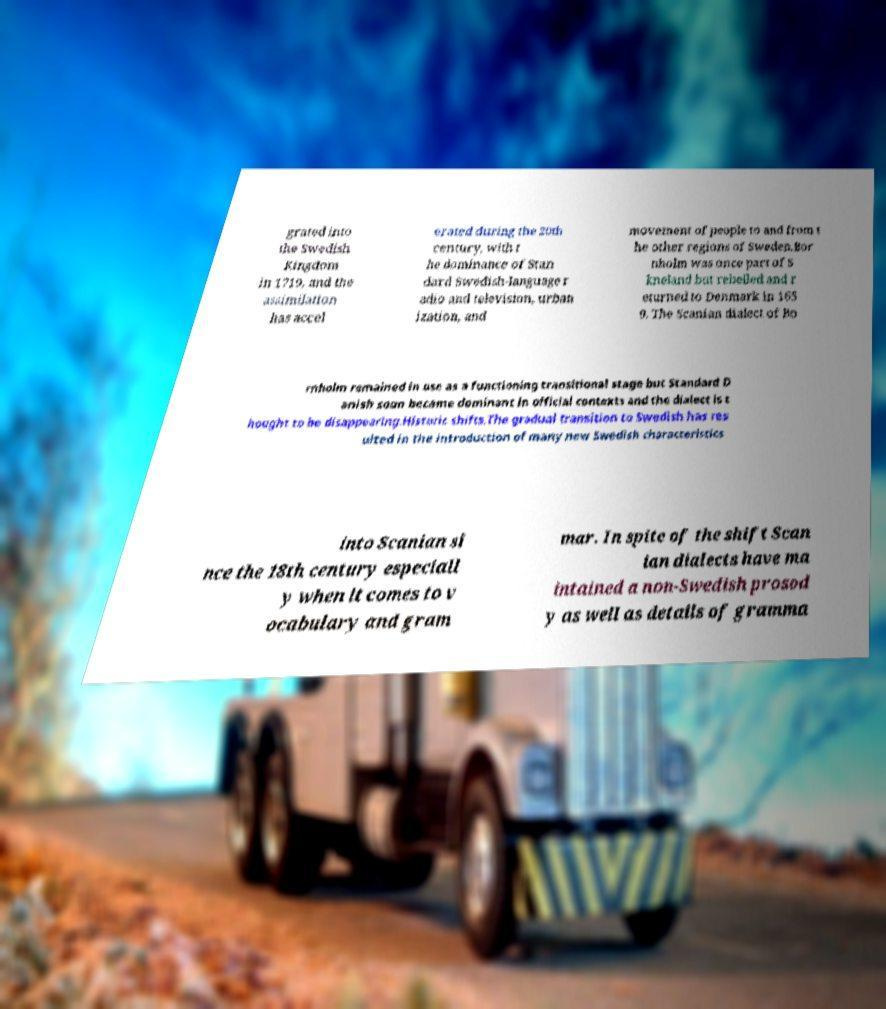For documentation purposes, I need the text within this image transcribed. Could you provide that? grated into the Swedish Kingdom in 1719, and the assimilation has accel erated during the 20th century, with t he dominance of Stan dard Swedish-language r adio and television, urban ization, and movement of people to and from t he other regions of Sweden.Bor nholm was once part of S kneland but rebelled and r eturned to Denmark in 165 9. The Scanian dialect of Bo rnholm remained in use as a functioning transitional stage but Standard D anish soon became dominant in official contexts and the dialect is t hought to be disappearing.Historic shifts.The gradual transition to Swedish has res ulted in the introduction of many new Swedish characteristics into Scanian si nce the 18th century especiall y when it comes to v ocabulary and gram mar. In spite of the shift Scan ian dialects have ma intained a non-Swedish prosod y as well as details of gramma 